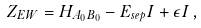<formula> <loc_0><loc_0><loc_500><loc_500>Z _ { E W } = H _ { A _ { 0 } B _ { 0 } } - E _ { s e p } I + \epsilon I \, ,</formula> 